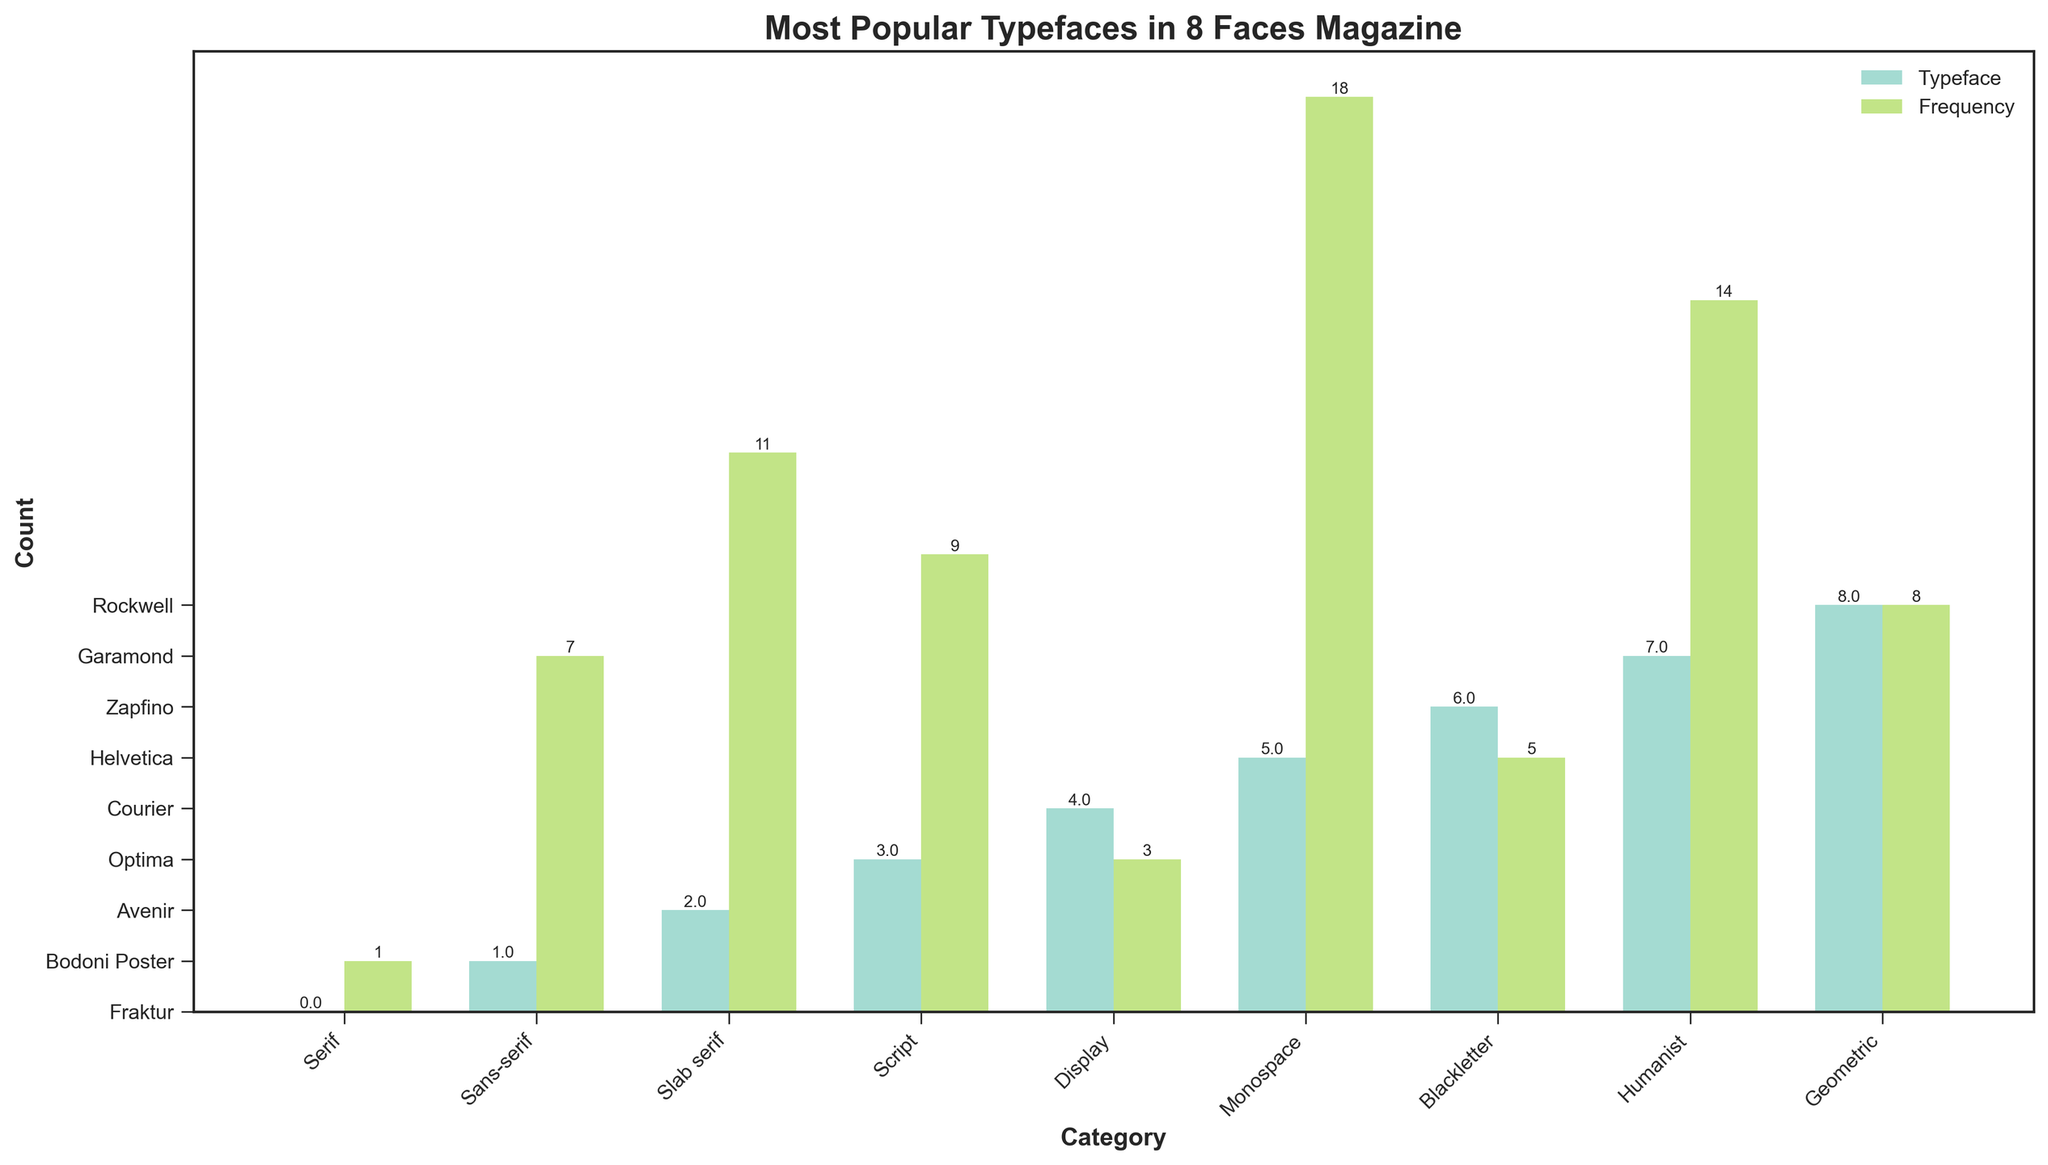Which category has the highest frequency for a typeface? To find the category with the highest frequency for a typeface, look for the highest bar in the chart. The highest bar is in the "Sans-serif" category.
Answer: Sans-serif Which typeface within the "Serif" category has the highest count? Within the "Serif" category, compare the heights of the bars for "Garamond" and "Baskerville." Garamond has the higher bar.
Answer: Garamond What is the total frequency of all "Script" typefaces combined? Add the heights of the bars for the "Script" typefaces: Zapfino (5) and Brush Script (4). The sum is 5 + 4 = 9.
Answer: 9 Which has more typefaces: "Sans-serif" or "Geometric"? Count the bars within the "Sans-serif" and "Geometric" categories. "Sans-serif" has 2 typefaces (Helvetica, Futura), and "Geometric" also has 2 (Avenir, Gotham). So, they are equal.
Answer: Equal Which typeface category has the least total frequency, and what is that frequency? Each category's total frequency is the sum of its typefaces’ frequencies. The category with the least total is "Blackletter" with a total of 2 (Fraktur and Old English, each 1).
Answer: Blackletter, 2 By how many units does the frequency of "Rockwell" exceed "Clarendon"? Subtract the frequency of "Clarendon" (6) from that of "Rockwell" (8). The difference is 8 - 6 = 2.
Answer: 2 What is the average frequency of typefaces in the "Display" category? Add the frequencies of "Display" typefaces: Bodoni Poster (7) and Trajan (6), and divide by the number of typefaces. The calculation is (7 + 6) / 2 = 6.5.
Answer: 6.5 Are there any categories that feature exactly two typefaces? Review each category to see if there are exactly two bars. Categories with exactly two typefaces are "Serif," "Sans-serif," "Slab serif," "Script," "Display," "Monospace," "Blackletter," "Humanist," and "Geometric."
Answer: Yes Which category has the second highest frequency typeface and what is that typeface? Identify the second highest bar overall. Futura in the "Sans-serif" category has the second highest frequency (15).
Answer: Sans-serif, Futura Is the height of the bar for "Optima" greater than that of "Gill Sans"? Compare the bars for Optima (9) and Gill Sans (7). Optima is greater than Gill Sans.
Answer: Yes 